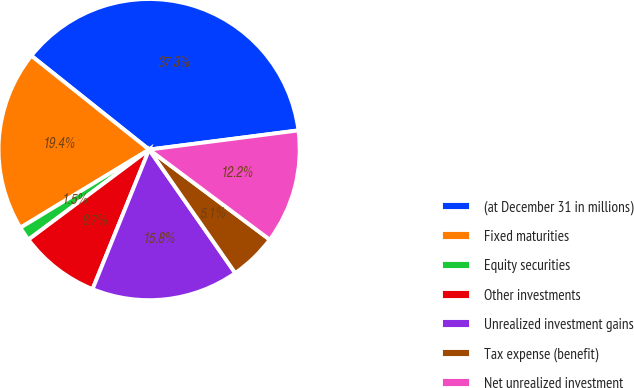<chart> <loc_0><loc_0><loc_500><loc_500><pie_chart><fcel>(at December 31 in millions)<fcel>Fixed maturities<fcel>Equity securities<fcel>Other investments<fcel>Unrealized investment gains<fcel>Tax expense (benefit)<fcel>Net unrealized investment<nl><fcel>37.26%<fcel>19.39%<fcel>1.52%<fcel>8.67%<fcel>15.82%<fcel>5.1%<fcel>12.24%<nl></chart> 